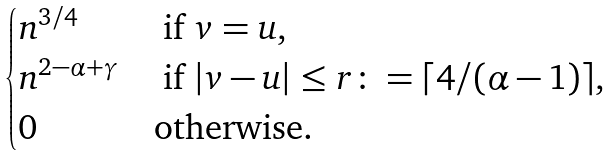<formula> <loc_0><loc_0><loc_500><loc_500>\begin{cases} n ^ { 3 / 4 } & \text { if } v = u , \\ n ^ { 2 - \alpha + \gamma } & \text { if } | v - u | \leq r \colon = \lceil 4 / ( \alpha - 1 ) \rceil , \\ 0 & \text {otherwise} . \end{cases}</formula> 